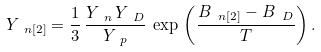<formula> <loc_0><loc_0><loc_500><loc_500>Y _ { \ n [ 2 ] } = \frac { 1 } { 3 } \, \frac { Y _ { \ n } \, Y _ { \ D } } { Y _ { \ p } } \, \exp \, \left ( \frac { B _ { \ n [ 2 ] } - B _ { \ D } } { T } \right ) .</formula> 